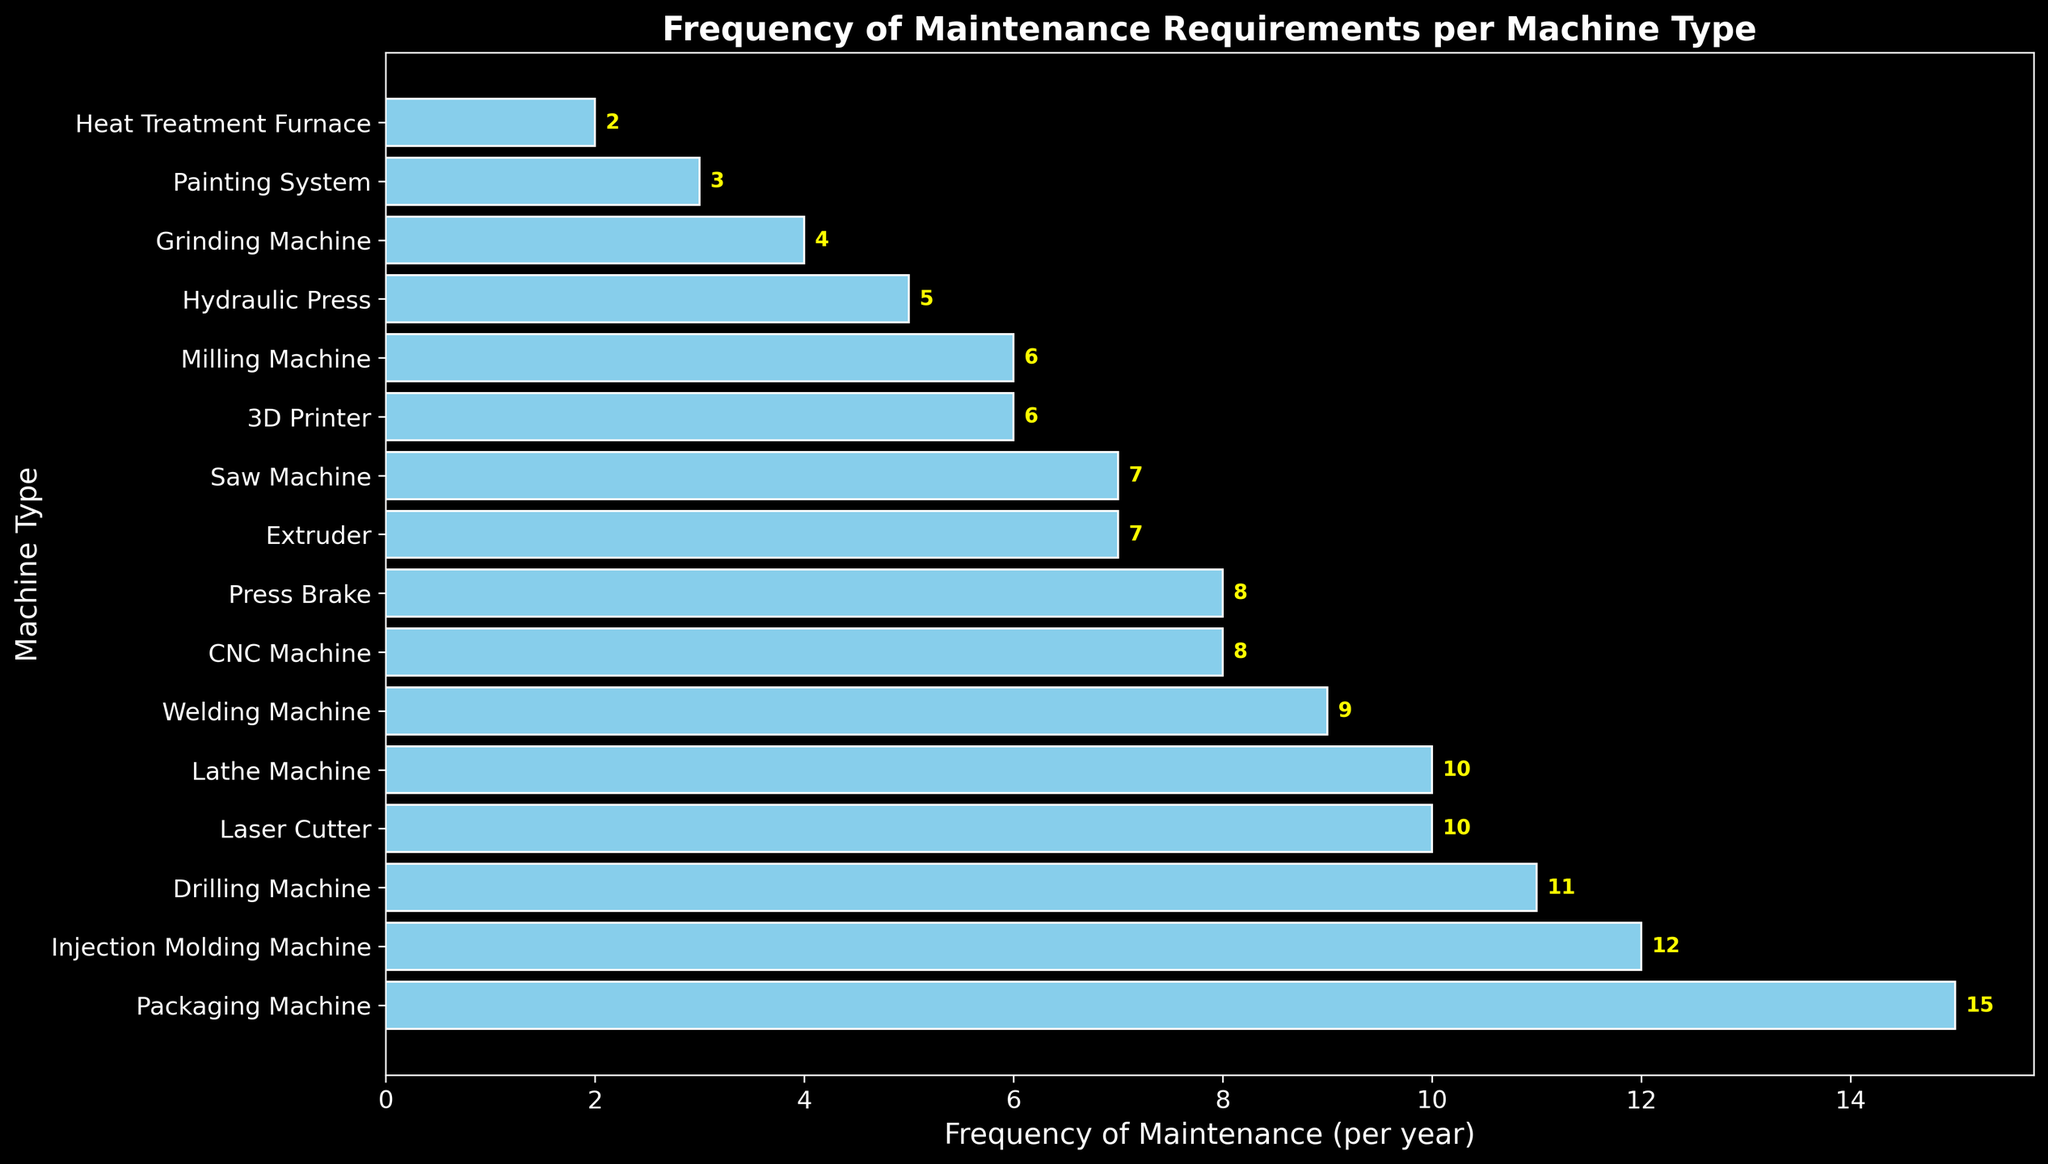What's the total frequency of maintenance required for all machines? Add up the frequencies from all the bars: 15 (Packaging Machine) + 12 (Injection Molding Machine) + 11 (Drilling Machine) + 10 (Laser Cutter) + 10 (Lathe Machine) + 9 (Welding Machine) + 8 (CNC Machine) + 8 (Press Brake) + 7 (Extruder) + 7 (Saw Machine) + 6 (3D Printer) + 6 (Milling Machine) + 5 (Hydraulic Press) + 4 (Grinding Machine) + 3 (Painting System) + 2 (Heat Treatment Furnace) = 123
Answer: 123 Which machine types require maintenance less frequently than the average frequency? First, find the average frequency: Total frequency (123) divided by the number of machines (16) equals 7.6875. Machines with frequencies less than 7.6875 are Hydraulic Press (5), Grinding Machine (4), Painting System (3), and Heat Treatment Furnace (2).
Answer: Hydraulic Press, Grinding Machine, Painting System, Heat Treatment Furnace Which machine has the highest frequency of maintenance? Locate the longest bar which represents the Packaging Machine with a frequency of maintenance per year of 15.
Answer: Packaging Machine How much more frequently does the Packaging Machine require maintenance compared to the Hydraulic Press? Subtract the frequency of the Hydraulic Press (5) from the Packaging Machine (15): 15 - 5 = 10.
Answer: 10 Are there any machines that require maintenance exactly 8 times per year? If so, which ones? Look for bars with a value of 8. The CNC Machine and Press Brake both meet this criterion.
Answer: CNC Machine, Press Brake 